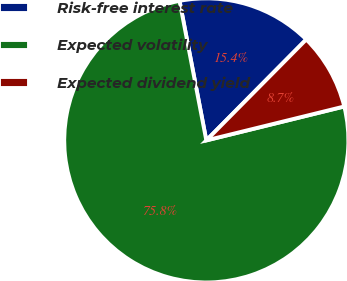Convert chart to OTSL. <chart><loc_0><loc_0><loc_500><loc_500><pie_chart><fcel>Risk-free interest rate<fcel>Expected volatility<fcel>Expected dividend yield<nl><fcel>15.44%<fcel>75.82%<fcel>8.74%<nl></chart> 